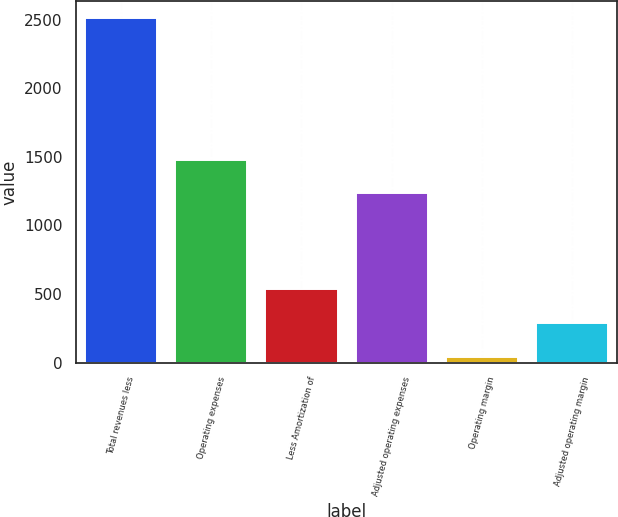Convert chart. <chart><loc_0><loc_0><loc_500><loc_500><bar_chart><fcel>Total revenues less<fcel>Operating expenses<fcel>Less Amortization of<fcel>Adjusted operating expenses<fcel>Operating margin<fcel>Adjusted operating margin<nl><fcel>2510<fcel>1479.9<fcel>534.8<fcel>1233<fcel>41<fcel>287.9<nl></chart> 